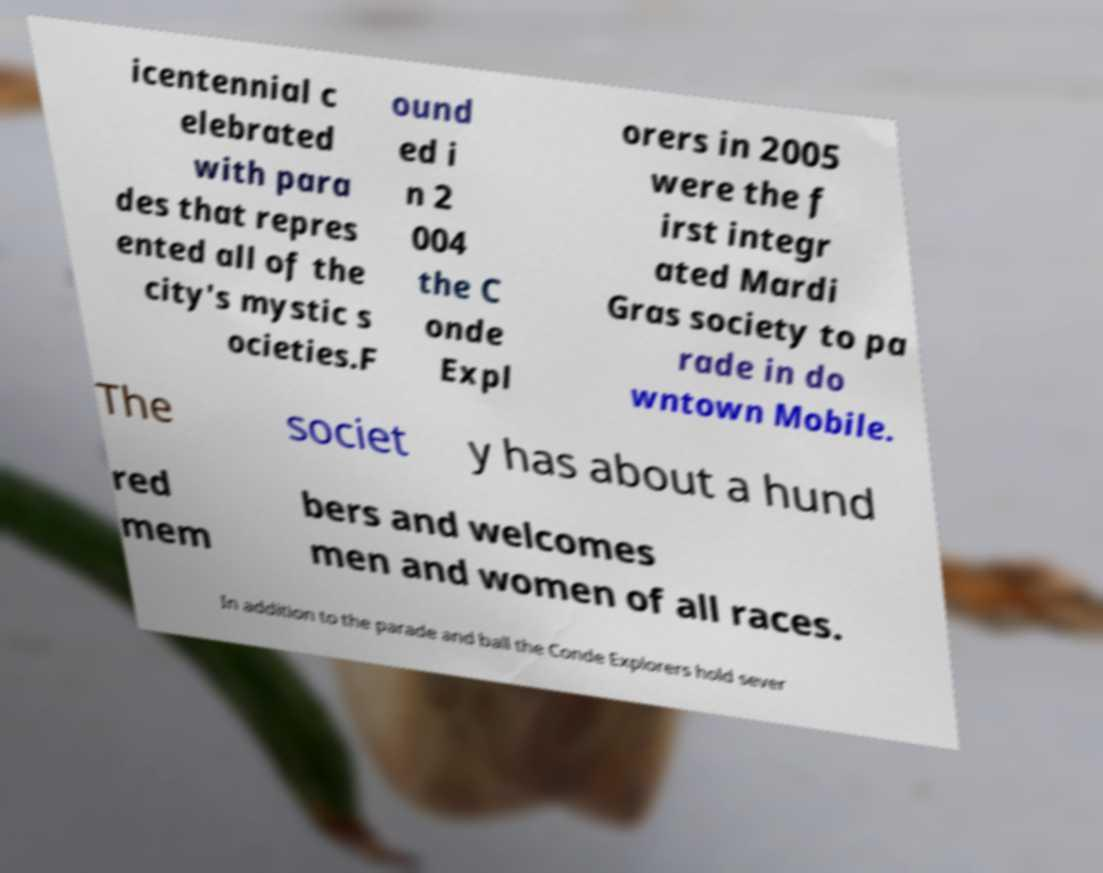What messages or text are displayed in this image? I need them in a readable, typed format. icentennial c elebrated with para des that repres ented all of the city's mystic s ocieties.F ound ed i n 2 004 the C onde Expl orers in 2005 were the f irst integr ated Mardi Gras society to pa rade in do wntown Mobile. The societ y has about a hund red mem bers and welcomes men and women of all races. In addition to the parade and ball the Conde Explorers hold sever 